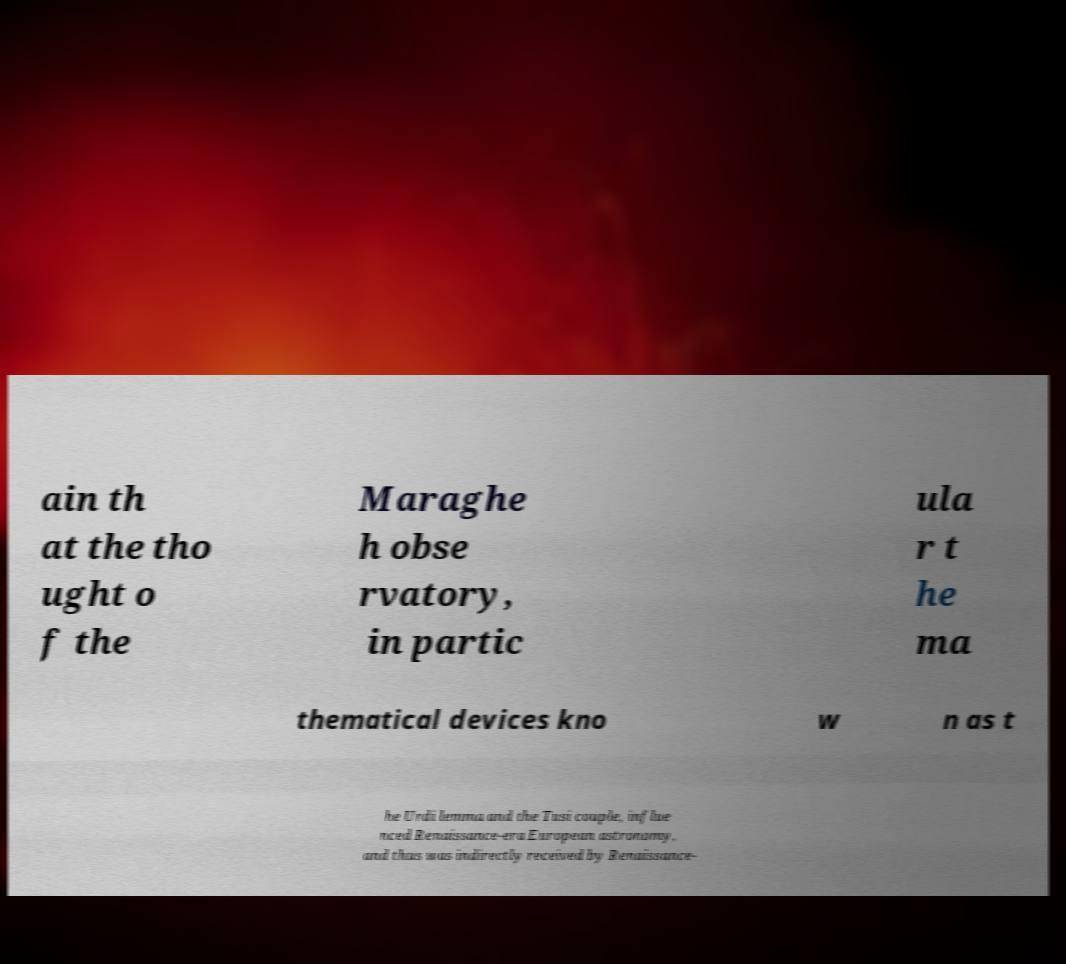Could you assist in decoding the text presented in this image and type it out clearly? ain th at the tho ught o f the Maraghe h obse rvatory, in partic ula r t he ma thematical devices kno w n as t he Urdi lemma and the Tusi couple, influe nced Renaissance-era European astronomy, and thus was indirectly received by Renaissance- 